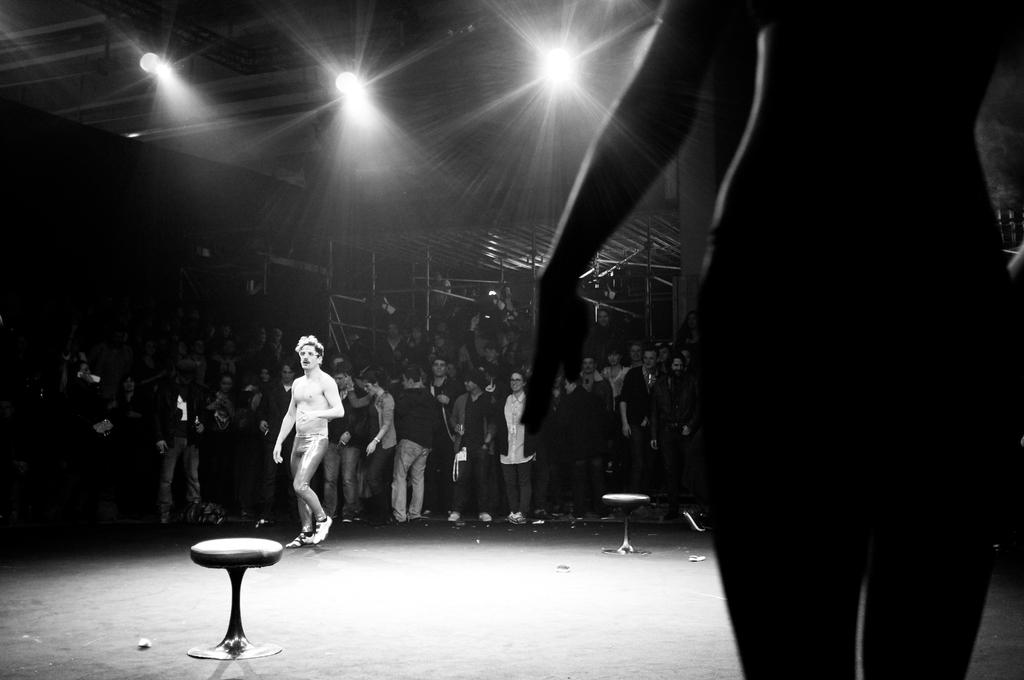Who is the main subject in the image? There is a boy in the image. What is the boy wearing? The boy is wearing a painted costume. What is the boy doing in the image? The boy is walking. Are there any other people in the image? Yes, there are people standing and observing the boy. What can be seen at the top of the image? There are lights visible at the top of the image. What type of nerve is being stimulated by the doctor in the image? There is no doctor present in the image, and therefore no nerve stimulation is taking place. 